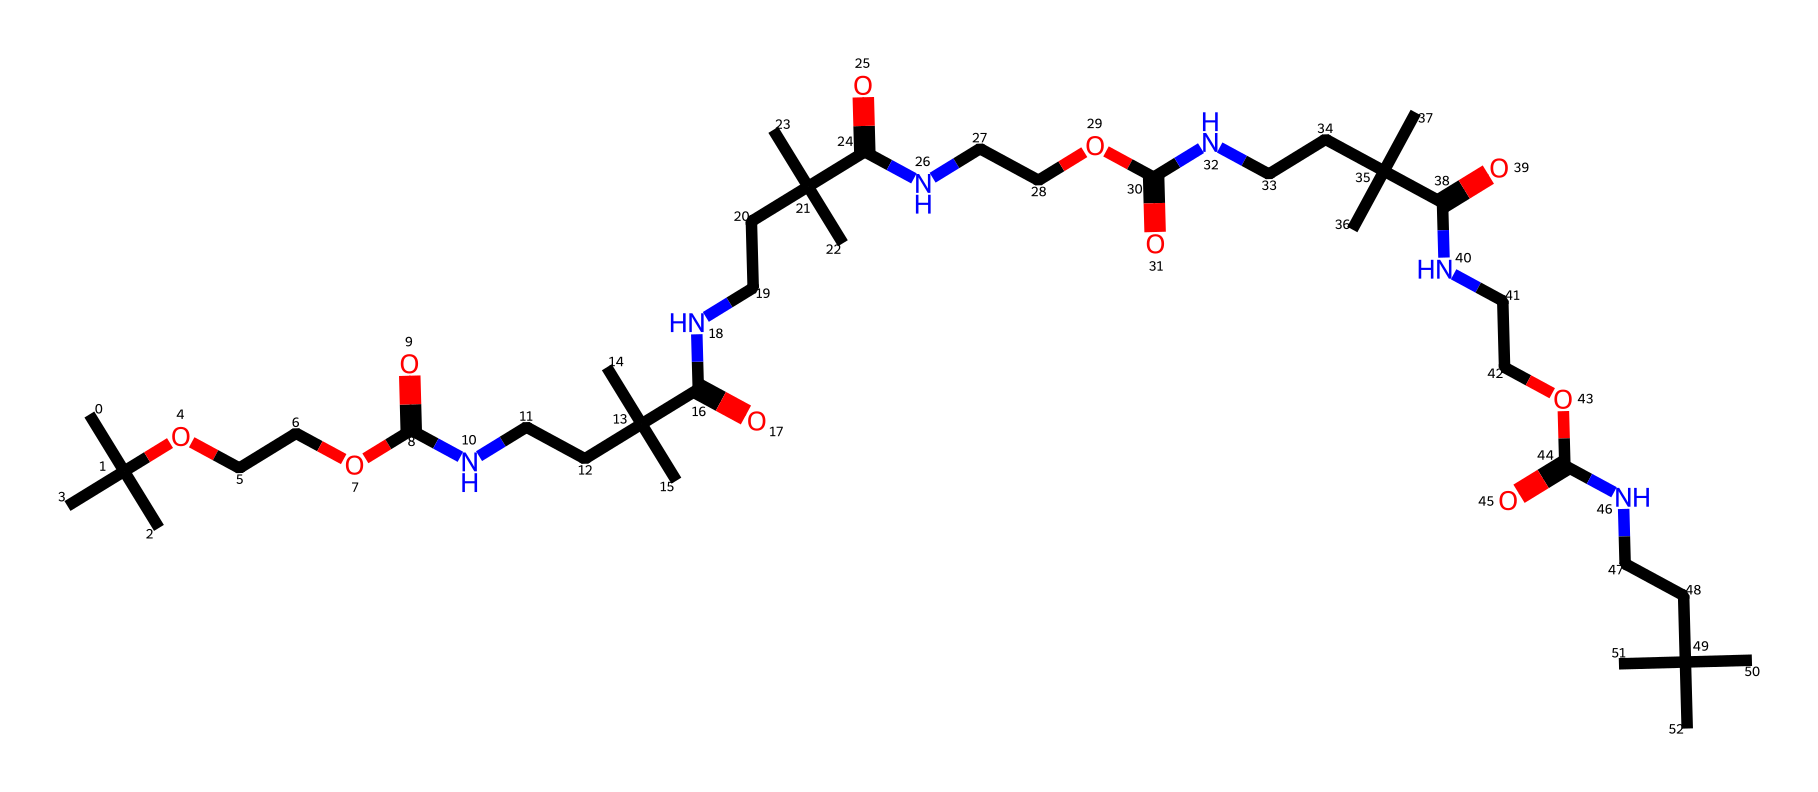What is the primary functional group present in this polyurethane structure? The primary functional group in this structure is the urethane group, which is identified by the presence of the carbonyl group (C=O) adjacent to a nitrogen atom (N), forming the -R-NH-CO- group.
Answer: urethane How many nitrogen atoms are in this chemical structure? By analyzing the SMILES representation, there are five instances of 'N' indicating that there are five nitrogen atoms present in the structure.
Answer: five What type of bond connects the carbon and nitrogen atoms in this polyurethane? The bond connecting carbon and nitrogen atoms in this structure is a covalent bond, typically formed between the carbon in the urethane group and the nitrogen.
Answer: covalent Which part of the structure contributes to its elasticity? The polyurethanes have long hydrocarbon chains that provide flexibility and elasticity, as seen in the repeating C-C units in the SMILES, contributing to its ability to deform under stress.
Answer: hydrocarbon chains How many ester linkages are present in the polyurethane structure? The presence of ester functional groups can be observed from the parts with -OC(=O)-, which appears four times in the structure indicating four distinct ester linkages.
Answer: four What does the high number of branching in this structure suggest about its properties? The extensive branching in the molecular structure indicates that the polyurethane will likely have high impact resistance and durability, which are desirable properties for skateboard wheels.
Answer: high impact resistance What is the significance of the bulky alkyl groups in the polyurethane? The bulky alkyl groups enhance the material's toughness and resistance to wear, as they create a physical barrier that prevents chain mobility, contributing to the overall strength of the skateboard wheel.
Answer: toughness 